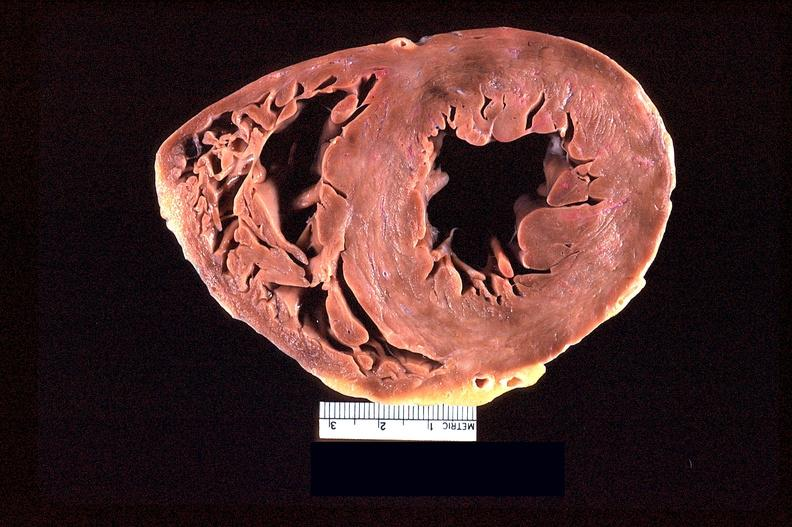does this image show heart slice, acute posterior myocardial infarction in patient with hypertension?
Answer the question using a single word or phrase. Yes 